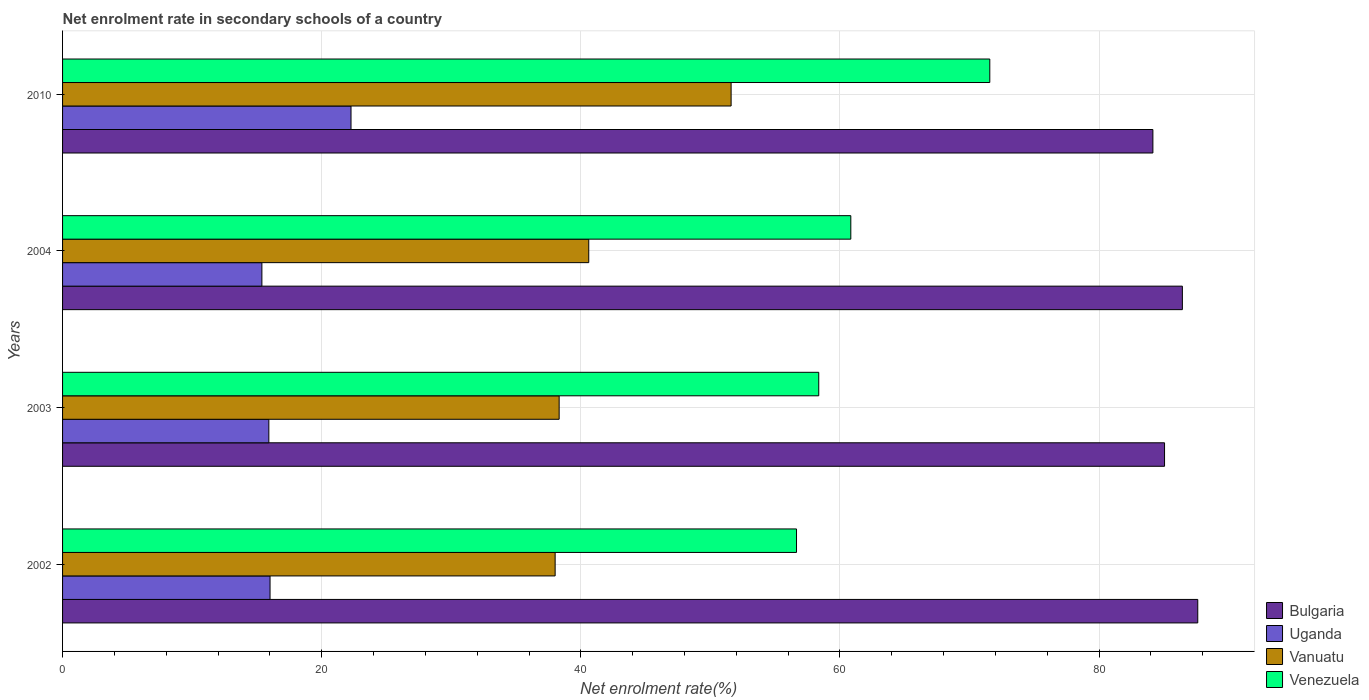How many groups of bars are there?
Offer a very short reply. 4. Are the number of bars per tick equal to the number of legend labels?
Your response must be concise. Yes. How many bars are there on the 2nd tick from the bottom?
Provide a succinct answer. 4. What is the label of the 3rd group of bars from the top?
Your response must be concise. 2003. What is the net enrolment rate in secondary schools in Vanuatu in 2010?
Your answer should be compact. 51.6. Across all years, what is the maximum net enrolment rate in secondary schools in Vanuatu?
Your response must be concise. 51.6. Across all years, what is the minimum net enrolment rate in secondary schools in Bulgaria?
Give a very brief answer. 84.15. In which year was the net enrolment rate in secondary schools in Vanuatu maximum?
Offer a terse response. 2010. In which year was the net enrolment rate in secondary schools in Vanuatu minimum?
Provide a short and direct response. 2002. What is the total net enrolment rate in secondary schools in Vanuatu in the graph?
Offer a very short reply. 168.56. What is the difference between the net enrolment rate in secondary schools in Venezuela in 2003 and that in 2010?
Provide a succinct answer. -13.2. What is the difference between the net enrolment rate in secondary schools in Vanuatu in 2010 and the net enrolment rate in secondary schools in Uganda in 2002?
Ensure brevity in your answer.  35.59. What is the average net enrolment rate in secondary schools in Bulgaria per year?
Offer a very short reply. 85.81. In the year 2010, what is the difference between the net enrolment rate in secondary schools in Vanuatu and net enrolment rate in secondary schools in Uganda?
Keep it short and to the point. 29.34. In how many years, is the net enrolment rate in secondary schools in Bulgaria greater than 52 %?
Make the answer very short. 4. What is the ratio of the net enrolment rate in secondary schools in Uganda in 2003 to that in 2004?
Your response must be concise. 1.03. Is the difference between the net enrolment rate in secondary schools in Vanuatu in 2002 and 2003 greater than the difference between the net enrolment rate in secondary schools in Uganda in 2002 and 2003?
Your answer should be compact. No. What is the difference between the highest and the second highest net enrolment rate in secondary schools in Bulgaria?
Give a very brief answer. 1.19. What is the difference between the highest and the lowest net enrolment rate in secondary schools in Venezuela?
Your answer should be compact. 14.92. In how many years, is the net enrolment rate in secondary schools in Venezuela greater than the average net enrolment rate in secondary schools in Venezuela taken over all years?
Provide a succinct answer. 1. Is the sum of the net enrolment rate in secondary schools in Uganda in 2003 and 2004 greater than the maximum net enrolment rate in secondary schools in Bulgaria across all years?
Ensure brevity in your answer.  No. Is it the case that in every year, the sum of the net enrolment rate in secondary schools in Bulgaria and net enrolment rate in secondary schools in Venezuela is greater than the sum of net enrolment rate in secondary schools in Uganda and net enrolment rate in secondary schools in Vanuatu?
Make the answer very short. Yes. What does the 4th bar from the bottom in 2003 represents?
Offer a very short reply. Venezuela. Is it the case that in every year, the sum of the net enrolment rate in secondary schools in Vanuatu and net enrolment rate in secondary schools in Uganda is greater than the net enrolment rate in secondary schools in Venezuela?
Offer a very short reply. No. How many years are there in the graph?
Ensure brevity in your answer.  4. Does the graph contain any zero values?
Provide a short and direct response. No. Where does the legend appear in the graph?
Offer a very short reply. Bottom right. How many legend labels are there?
Keep it short and to the point. 4. What is the title of the graph?
Offer a terse response. Net enrolment rate in secondary schools of a country. What is the label or title of the X-axis?
Offer a terse response. Net enrolment rate(%). What is the label or title of the Y-axis?
Make the answer very short. Years. What is the Net enrolment rate(%) in Bulgaria in 2002?
Your answer should be compact. 87.62. What is the Net enrolment rate(%) in Uganda in 2002?
Offer a very short reply. 16.01. What is the Net enrolment rate(%) of Vanuatu in 2002?
Keep it short and to the point. 38.02. What is the Net enrolment rate(%) in Venezuela in 2002?
Offer a very short reply. 56.65. What is the Net enrolment rate(%) in Bulgaria in 2003?
Keep it short and to the point. 85.05. What is the Net enrolment rate(%) in Uganda in 2003?
Your response must be concise. 15.92. What is the Net enrolment rate(%) of Vanuatu in 2003?
Give a very brief answer. 38.33. What is the Net enrolment rate(%) of Venezuela in 2003?
Offer a very short reply. 58.36. What is the Net enrolment rate(%) in Bulgaria in 2004?
Provide a succinct answer. 86.43. What is the Net enrolment rate(%) in Uganda in 2004?
Offer a very short reply. 15.38. What is the Net enrolment rate(%) in Vanuatu in 2004?
Your response must be concise. 40.61. What is the Net enrolment rate(%) of Venezuela in 2004?
Your response must be concise. 60.84. What is the Net enrolment rate(%) in Bulgaria in 2010?
Ensure brevity in your answer.  84.15. What is the Net enrolment rate(%) in Uganda in 2010?
Provide a short and direct response. 22.26. What is the Net enrolment rate(%) in Vanuatu in 2010?
Make the answer very short. 51.6. What is the Net enrolment rate(%) in Venezuela in 2010?
Offer a very short reply. 71.57. Across all years, what is the maximum Net enrolment rate(%) of Bulgaria?
Offer a very short reply. 87.62. Across all years, what is the maximum Net enrolment rate(%) of Uganda?
Keep it short and to the point. 22.26. Across all years, what is the maximum Net enrolment rate(%) of Vanuatu?
Your answer should be very brief. 51.6. Across all years, what is the maximum Net enrolment rate(%) in Venezuela?
Give a very brief answer. 71.57. Across all years, what is the minimum Net enrolment rate(%) in Bulgaria?
Make the answer very short. 84.15. Across all years, what is the minimum Net enrolment rate(%) of Uganda?
Make the answer very short. 15.38. Across all years, what is the minimum Net enrolment rate(%) in Vanuatu?
Your answer should be very brief. 38.02. Across all years, what is the minimum Net enrolment rate(%) in Venezuela?
Your answer should be compact. 56.65. What is the total Net enrolment rate(%) of Bulgaria in the graph?
Offer a very short reply. 343.25. What is the total Net enrolment rate(%) in Uganda in the graph?
Keep it short and to the point. 69.58. What is the total Net enrolment rate(%) of Vanuatu in the graph?
Give a very brief answer. 168.56. What is the total Net enrolment rate(%) of Venezuela in the graph?
Offer a very short reply. 247.42. What is the difference between the Net enrolment rate(%) in Bulgaria in 2002 and that in 2003?
Give a very brief answer. 2.56. What is the difference between the Net enrolment rate(%) in Uganda in 2002 and that in 2003?
Ensure brevity in your answer.  0.09. What is the difference between the Net enrolment rate(%) in Vanuatu in 2002 and that in 2003?
Give a very brief answer. -0.31. What is the difference between the Net enrolment rate(%) in Venezuela in 2002 and that in 2003?
Offer a terse response. -1.72. What is the difference between the Net enrolment rate(%) of Bulgaria in 2002 and that in 2004?
Provide a succinct answer. 1.19. What is the difference between the Net enrolment rate(%) of Uganda in 2002 and that in 2004?
Provide a short and direct response. 0.63. What is the difference between the Net enrolment rate(%) in Vanuatu in 2002 and that in 2004?
Provide a succinct answer. -2.59. What is the difference between the Net enrolment rate(%) in Venezuela in 2002 and that in 2004?
Give a very brief answer. -4.19. What is the difference between the Net enrolment rate(%) in Bulgaria in 2002 and that in 2010?
Offer a terse response. 3.46. What is the difference between the Net enrolment rate(%) in Uganda in 2002 and that in 2010?
Provide a short and direct response. -6.25. What is the difference between the Net enrolment rate(%) in Vanuatu in 2002 and that in 2010?
Provide a short and direct response. -13.58. What is the difference between the Net enrolment rate(%) of Venezuela in 2002 and that in 2010?
Your answer should be compact. -14.92. What is the difference between the Net enrolment rate(%) in Bulgaria in 2003 and that in 2004?
Ensure brevity in your answer.  -1.38. What is the difference between the Net enrolment rate(%) of Uganda in 2003 and that in 2004?
Offer a terse response. 0.54. What is the difference between the Net enrolment rate(%) in Vanuatu in 2003 and that in 2004?
Your response must be concise. -2.28. What is the difference between the Net enrolment rate(%) of Venezuela in 2003 and that in 2004?
Keep it short and to the point. -2.47. What is the difference between the Net enrolment rate(%) of Bulgaria in 2003 and that in 2010?
Offer a terse response. 0.9. What is the difference between the Net enrolment rate(%) of Uganda in 2003 and that in 2010?
Provide a short and direct response. -6.34. What is the difference between the Net enrolment rate(%) of Vanuatu in 2003 and that in 2010?
Offer a very short reply. -13.27. What is the difference between the Net enrolment rate(%) in Venezuela in 2003 and that in 2010?
Give a very brief answer. -13.2. What is the difference between the Net enrolment rate(%) of Bulgaria in 2004 and that in 2010?
Your answer should be very brief. 2.28. What is the difference between the Net enrolment rate(%) of Uganda in 2004 and that in 2010?
Provide a succinct answer. -6.88. What is the difference between the Net enrolment rate(%) of Vanuatu in 2004 and that in 2010?
Your answer should be compact. -10.99. What is the difference between the Net enrolment rate(%) of Venezuela in 2004 and that in 2010?
Make the answer very short. -10.73. What is the difference between the Net enrolment rate(%) of Bulgaria in 2002 and the Net enrolment rate(%) of Uganda in 2003?
Your response must be concise. 71.7. What is the difference between the Net enrolment rate(%) in Bulgaria in 2002 and the Net enrolment rate(%) in Vanuatu in 2003?
Your answer should be very brief. 49.29. What is the difference between the Net enrolment rate(%) of Bulgaria in 2002 and the Net enrolment rate(%) of Venezuela in 2003?
Your answer should be very brief. 29.25. What is the difference between the Net enrolment rate(%) in Uganda in 2002 and the Net enrolment rate(%) in Vanuatu in 2003?
Your answer should be very brief. -22.31. What is the difference between the Net enrolment rate(%) in Uganda in 2002 and the Net enrolment rate(%) in Venezuela in 2003?
Provide a succinct answer. -42.35. What is the difference between the Net enrolment rate(%) in Vanuatu in 2002 and the Net enrolment rate(%) in Venezuela in 2003?
Keep it short and to the point. -20.35. What is the difference between the Net enrolment rate(%) of Bulgaria in 2002 and the Net enrolment rate(%) of Uganda in 2004?
Offer a very short reply. 72.23. What is the difference between the Net enrolment rate(%) in Bulgaria in 2002 and the Net enrolment rate(%) in Vanuatu in 2004?
Give a very brief answer. 47.01. What is the difference between the Net enrolment rate(%) in Bulgaria in 2002 and the Net enrolment rate(%) in Venezuela in 2004?
Ensure brevity in your answer.  26.78. What is the difference between the Net enrolment rate(%) in Uganda in 2002 and the Net enrolment rate(%) in Vanuatu in 2004?
Your response must be concise. -24.6. What is the difference between the Net enrolment rate(%) of Uganda in 2002 and the Net enrolment rate(%) of Venezuela in 2004?
Your answer should be compact. -44.83. What is the difference between the Net enrolment rate(%) in Vanuatu in 2002 and the Net enrolment rate(%) in Venezuela in 2004?
Give a very brief answer. -22.82. What is the difference between the Net enrolment rate(%) of Bulgaria in 2002 and the Net enrolment rate(%) of Uganda in 2010?
Make the answer very short. 65.35. What is the difference between the Net enrolment rate(%) in Bulgaria in 2002 and the Net enrolment rate(%) in Vanuatu in 2010?
Your answer should be compact. 36.02. What is the difference between the Net enrolment rate(%) in Bulgaria in 2002 and the Net enrolment rate(%) in Venezuela in 2010?
Offer a terse response. 16.05. What is the difference between the Net enrolment rate(%) of Uganda in 2002 and the Net enrolment rate(%) of Vanuatu in 2010?
Offer a terse response. -35.59. What is the difference between the Net enrolment rate(%) in Uganda in 2002 and the Net enrolment rate(%) in Venezuela in 2010?
Your response must be concise. -55.55. What is the difference between the Net enrolment rate(%) in Vanuatu in 2002 and the Net enrolment rate(%) in Venezuela in 2010?
Give a very brief answer. -33.55. What is the difference between the Net enrolment rate(%) in Bulgaria in 2003 and the Net enrolment rate(%) in Uganda in 2004?
Your response must be concise. 69.67. What is the difference between the Net enrolment rate(%) of Bulgaria in 2003 and the Net enrolment rate(%) of Vanuatu in 2004?
Your answer should be very brief. 44.44. What is the difference between the Net enrolment rate(%) of Bulgaria in 2003 and the Net enrolment rate(%) of Venezuela in 2004?
Ensure brevity in your answer.  24.21. What is the difference between the Net enrolment rate(%) of Uganda in 2003 and the Net enrolment rate(%) of Vanuatu in 2004?
Offer a terse response. -24.69. What is the difference between the Net enrolment rate(%) of Uganda in 2003 and the Net enrolment rate(%) of Venezuela in 2004?
Make the answer very short. -44.92. What is the difference between the Net enrolment rate(%) of Vanuatu in 2003 and the Net enrolment rate(%) of Venezuela in 2004?
Give a very brief answer. -22.51. What is the difference between the Net enrolment rate(%) of Bulgaria in 2003 and the Net enrolment rate(%) of Uganda in 2010?
Give a very brief answer. 62.79. What is the difference between the Net enrolment rate(%) of Bulgaria in 2003 and the Net enrolment rate(%) of Vanuatu in 2010?
Your response must be concise. 33.45. What is the difference between the Net enrolment rate(%) of Bulgaria in 2003 and the Net enrolment rate(%) of Venezuela in 2010?
Offer a terse response. 13.49. What is the difference between the Net enrolment rate(%) of Uganda in 2003 and the Net enrolment rate(%) of Vanuatu in 2010?
Provide a succinct answer. -35.68. What is the difference between the Net enrolment rate(%) of Uganda in 2003 and the Net enrolment rate(%) of Venezuela in 2010?
Your answer should be very brief. -55.64. What is the difference between the Net enrolment rate(%) in Vanuatu in 2003 and the Net enrolment rate(%) in Venezuela in 2010?
Offer a very short reply. -33.24. What is the difference between the Net enrolment rate(%) in Bulgaria in 2004 and the Net enrolment rate(%) in Uganda in 2010?
Ensure brevity in your answer.  64.17. What is the difference between the Net enrolment rate(%) in Bulgaria in 2004 and the Net enrolment rate(%) in Vanuatu in 2010?
Offer a terse response. 34.83. What is the difference between the Net enrolment rate(%) of Bulgaria in 2004 and the Net enrolment rate(%) of Venezuela in 2010?
Provide a succinct answer. 14.86. What is the difference between the Net enrolment rate(%) of Uganda in 2004 and the Net enrolment rate(%) of Vanuatu in 2010?
Provide a succinct answer. -36.22. What is the difference between the Net enrolment rate(%) in Uganda in 2004 and the Net enrolment rate(%) in Venezuela in 2010?
Make the answer very short. -56.18. What is the difference between the Net enrolment rate(%) of Vanuatu in 2004 and the Net enrolment rate(%) of Venezuela in 2010?
Make the answer very short. -30.95. What is the average Net enrolment rate(%) in Bulgaria per year?
Provide a succinct answer. 85.81. What is the average Net enrolment rate(%) in Uganda per year?
Make the answer very short. 17.4. What is the average Net enrolment rate(%) in Vanuatu per year?
Your answer should be compact. 42.14. What is the average Net enrolment rate(%) in Venezuela per year?
Provide a short and direct response. 61.85. In the year 2002, what is the difference between the Net enrolment rate(%) of Bulgaria and Net enrolment rate(%) of Uganda?
Provide a short and direct response. 71.6. In the year 2002, what is the difference between the Net enrolment rate(%) in Bulgaria and Net enrolment rate(%) in Vanuatu?
Make the answer very short. 49.6. In the year 2002, what is the difference between the Net enrolment rate(%) of Bulgaria and Net enrolment rate(%) of Venezuela?
Offer a terse response. 30.97. In the year 2002, what is the difference between the Net enrolment rate(%) of Uganda and Net enrolment rate(%) of Vanuatu?
Provide a succinct answer. -22. In the year 2002, what is the difference between the Net enrolment rate(%) in Uganda and Net enrolment rate(%) in Venezuela?
Your answer should be compact. -40.63. In the year 2002, what is the difference between the Net enrolment rate(%) in Vanuatu and Net enrolment rate(%) in Venezuela?
Keep it short and to the point. -18.63. In the year 2003, what is the difference between the Net enrolment rate(%) in Bulgaria and Net enrolment rate(%) in Uganda?
Ensure brevity in your answer.  69.13. In the year 2003, what is the difference between the Net enrolment rate(%) in Bulgaria and Net enrolment rate(%) in Vanuatu?
Ensure brevity in your answer.  46.73. In the year 2003, what is the difference between the Net enrolment rate(%) in Bulgaria and Net enrolment rate(%) in Venezuela?
Offer a terse response. 26.69. In the year 2003, what is the difference between the Net enrolment rate(%) of Uganda and Net enrolment rate(%) of Vanuatu?
Keep it short and to the point. -22.41. In the year 2003, what is the difference between the Net enrolment rate(%) in Uganda and Net enrolment rate(%) in Venezuela?
Provide a succinct answer. -42.44. In the year 2003, what is the difference between the Net enrolment rate(%) in Vanuatu and Net enrolment rate(%) in Venezuela?
Your answer should be compact. -20.04. In the year 2004, what is the difference between the Net enrolment rate(%) in Bulgaria and Net enrolment rate(%) in Uganda?
Make the answer very short. 71.05. In the year 2004, what is the difference between the Net enrolment rate(%) of Bulgaria and Net enrolment rate(%) of Vanuatu?
Your answer should be compact. 45.82. In the year 2004, what is the difference between the Net enrolment rate(%) in Bulgaria and Net enrolment rate(%) in Venezuela?
Offer a very short reply. 25.59. In the year 2004, what is the difference between the Net enrolment rate(%) in Uganda and Net enrolment rate(%) in Vanuatu?
Ensure brevity in your answer.  -25.23. In the year 2004, what is the difference between the Net enrolment rate(%) of Uganda and Net enrolment rate(%) of Venezuela?
Offer a terse response. -45.45. In the year 2004, what is the difference between the Net enrolment rate(%) in Vanuatu and Net enrolment rate(%) in Venezuela?
Your answer should be very brief. -20.23. In the year 2010, what is the difference between the Net enrolment rate(%) of Bulgaria and Net enrolment rate(%) of Uganda?
Your answer should be compact. 61.89. In the year 2010, what is the difference between the Net enrolment rate(%) in Bulgaria and Net enrolment rate(%) in Vanuatu?
Provide a succinct answer. 32.55. In the year 2010, what is the difference between the Net enrolment rate(%) in Bulgaria and Net enrolment rate(%) in Venezuela?
Ensure brevity in your answer.  12.59. In the year 2010, what is the difference between the Net enrolment rate(%) in Uganda and Net enrolment rate(%) in Vanuatu?
Your answer should be very brief. -29.34. In the year 2010, what is the difference between the Net enrolment rate(%) in Uganda and Net enrolment rate(%) in Venezuela?
Make the answer very short. -49.3. In the year 2010, what is the difference between the Net enrolment rate(%) of Vanuatu and Net enrolment rate(%) of Venezuela?
Give a very brief answer. -19.97. What is the ratio of the Net enrolment rate(%) in Bulgaria in 2002 to that in 2003?
Offer a very short reply. 1.03. What is the ratio of the Net enrolment rate(%) in Uganda in 2002 to that in 2003?
Make the answer very short. 1.01. What is the ratio of the Net enrolment rate(%) of Vanuatu in 2002 to that in 2003?
Give a very brief answer. 0.99. What is the ratio of the Net enrolment rate(%) in Venezuela in 2002 to that in 2003?
Provide a short and direct response. 0.97. What is the ratio of the Net enrolment rate(%) of Bulgaria in 2002 to that in 2004?
Provide a short and direct response. 1.01. What is the ratio of the Net enrolment rate(%) in Uganda in 2002 to that in 2004?
Ensure brevity in your answer.  1.04. What is the ratio of the Net enrolment rate(%) of Vanuatu in 2002 to that in 2004?
Ensure brevity in your answer.  0.94. What is the ratio of the Net enrolment rate(%) of Venezuela in 2002 to that in 2004?
Make the answer very short. 0.93. What is the ratio of the Net enrolment rate(%) of Bulgaria in 2002 to that in 2010?
Keep it short and to the point. 1.04. What is the ratio of the Net enrolment rate(%) in Uganda in 2002 to that in 2010?
Your answer should be compact. 0.72. What is the ratio of the Net enrolment rate(%) in Vanuatu in 2002 to that in 2010?
Provide a succinct answer. 0.74. What is the ratio of the Net enrolment rate(%) in Venezuela in 2002 to that in 2010?
Your answer should be very brief. 0.79. What is the ratio of the Net enrolment rate(%) of Bulgaria in 2003 to that in 2004?
Offer a very short reply. 0.98. What is the ratio of the Net enrolment rate(%) in Uganda in 2003 to that in 2004?
Provide a short and direct response. 1.03. What is the ratio of the Net enrolment rate(%) in Vanuatu in 2003 to that in 2004?
Your answer should be very brief. 0.94. What is the ratio of the Net enrolment rate(%) of Venezuela in 2003 to that in 2004?
Your response must be concise. 0.96. What is the ratio of the Net enrolment rate(%) of Bulgaria in 2003 to that in 2010?
Ensure brevity in your answer.  1.01. What is the ratio of the Net enrolment rate(%) of Uganda in 2003 to that in 2010?
Your answer should be very brief. 0.72. What is the ratio of the Net enrolment rate(%) of Vanuatu in 2003 to that in 2010?
Ensure brevity in your answer.  0.74. What is the ratio of the Net enrolment rate(%) of Venezuela in 2003 to that in 2010?
Your response must be concise. 0.82. What is the ratio of the Net enrolment rate(%) in Bulgaria in 2004 to that in 2010?
Offer a very short reply. 1.03. What is the ratio of the Net enrolment rate(%) of Uganda in 2004 to that in 2010?
Make the answer very short. 0.69. What is the ratio of the Net enrolment rate(%) in Vanuatu in 2004 to that in 2010?
Your answer should be very brief. 0.79. What is the ratio of the Net enrolment rate(%) of Venezuela in 2004 to that in 2010?
Offer a very short reply. 0.85. What is the difference between the highest and the second highest Net enrolment rate(%) in Bulgaria?
Offer a terse response. 1.19. What is the difference between the highest and the second highest Net enrolment rate(%) in Uganda?
Offer a terse response. 6.25. What is the difference between the highest and the second highest Net enrolment rate(%) of Vanuatu?
Your answer should be very brief. 10.99. What is the difference between the highest and the second highest Net enrolment rate(%) in Venezuela?
Ensure brevity in your answer.  10.73. What is the difference between the highest and the lowest Net enrolment rate(%) in Bulgaria?
Make the answer very short. 3.46. What is the difference between the highest and the lowest Net enrolment rate(%) in Uganda?
Your response must be concise. 6.88. What is the difference between the highest and the lowest Net enrolment rate(%) of Vanuatu?
Keep it short and to the point. 13.58. What is the difference between the highest and the lowest Net enrolment rate(%) of Venezuela?
Offer a very short reply. 14.92. 